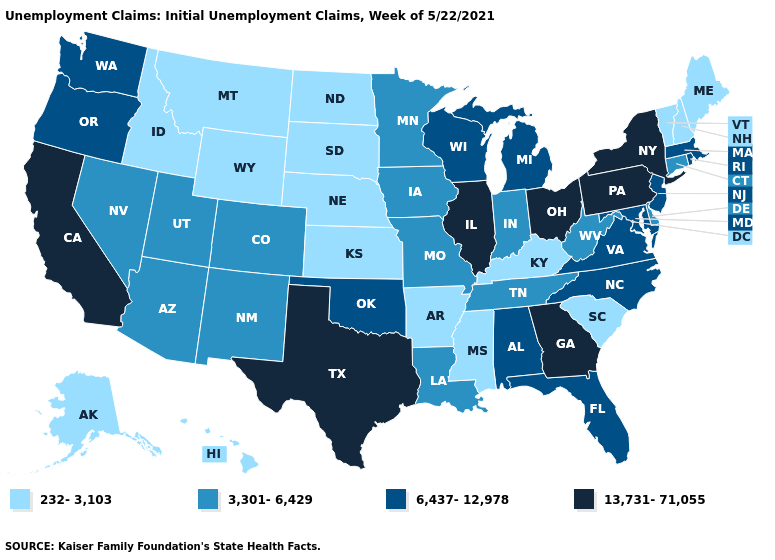What is the value of Kansas?
Answer briefly. 232-3,103. Name the states that have a value in the range 6,437-12,978?
Keep it brief. Alabama, Florida, Maryland, Massachusetts, Michigan, New Jersey, North Carolina, Oklahoma, Oregon, Rhode Island, Virginia, Washington, Wisconsin. What is the value of New Jersey?
Give a very brief answer. 6,437-12,978. What is the lowest value in states that border Mississippi?
Give a very brief answer. 232-3,103. Name the states that have a value in the range 6,437-12,978?
Answer briefly. Alabama, Florida, Maryland, Massachusetts, Michigan, New Jersey, North Carolina, Oklahoma, Oregon, Rhode Island, Virginia, Washington, Wisconsin. Does Nebraska have the highest value in the USA?
Give a very brief answer. No. What is the value of Michigan?
Concise answer only. 6,437-12,978. What is the highest value in states that border Florida?
Short answer required. 13,731-71,055. What is the value of Maryland?
Be succinct. 6,437-12,978. Name the states that have a value in the range 6,437-12,978?
Quick response, please. Alabama, Florida, Maryland, Massachusetts, Michigan, New Jersey, North Carolina, Oklahoma, Oregon, Rhode Island, Virginia, Washington, Wisconsin. What is the lowest value in states that border North Dakota?
Concise answer only. 232-3,103. What is the lowest value in states that border Missouri?
Be succinct. 232-3,103. What is the lowest value in the South?
Be succinct. 232-3,103. Does the map have missing data?
Be succinct. No. What is the value of Indiana?
Concise answer only. 3,301-6,429. 